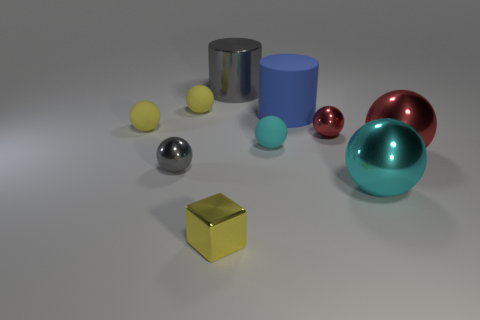Are there any objects in the image that could tell us more about the lighting and ambiance of the scene? Absolutely. The reflective surfaces of the metallic objects provide clues about the setting's lighting. The soft shadows and gentle highlights suggest a diffuse lighting environment, possibly from a source above, simulating a mellow, overcast daylight. The shadows are not harsh, which indicates the absence of a direct, strong light source. This carefully orchestrated lighting casts a serene ambiance, emphasizing the objects' textures and bringing forth the subtleties of their reflective properties. 